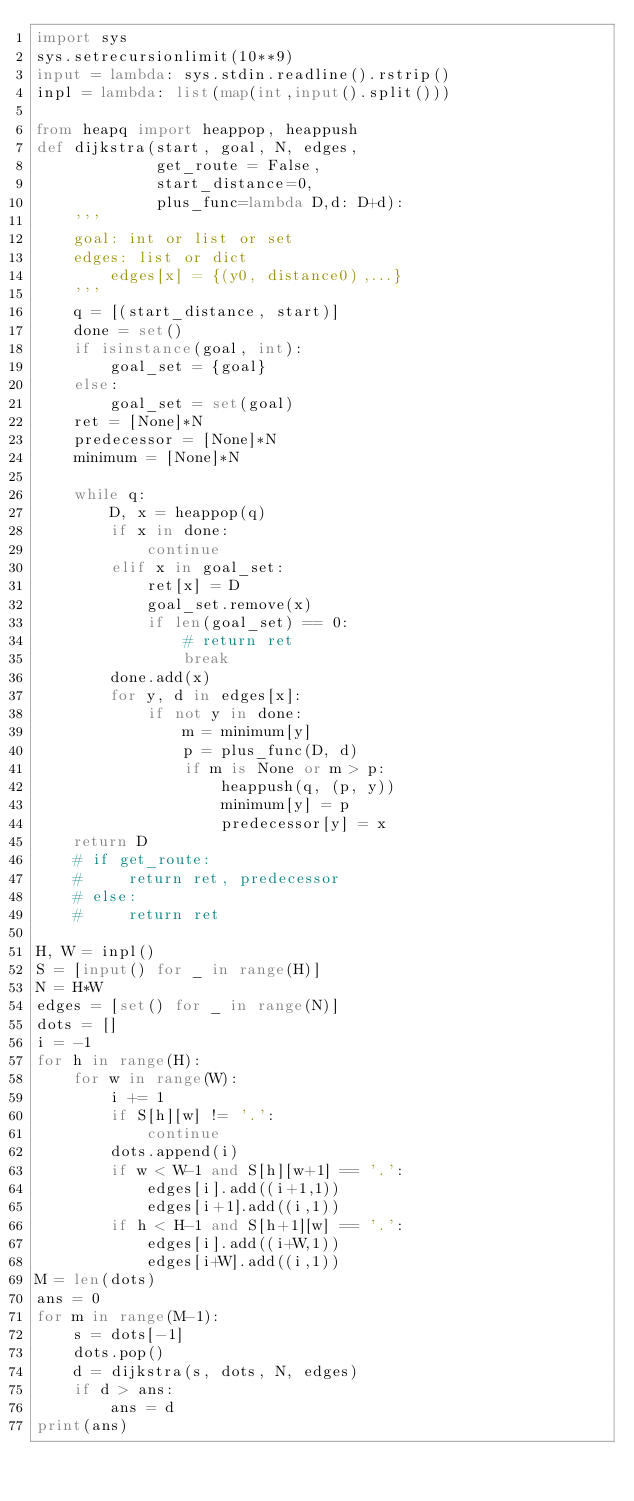<code> <loc_0><loc_0><loc_500><loc_500><_Python_>import sys
sys.setrecursionlimit(10**9)
input = lambda: sys.stdin.readline().rstrip()
inpl = lambda: list(map(int,input().split()))

from heapq import heappop, heappush
def dijkstra(start, goal, N, edges,
             get_route = False,
             start_distance=0,
             plus_func=lambda D,d: D+d):
    '''
    goal: int or list or set
    edges: list or dict
        edges[x] = {(y0, distance0),...}
    '''
    q = [(start_distance, start)]
    done = set()
    if isinstance(goal, int):
        goal_set = {goal}
    else:
        goal_set = set(goal)
    ret = [None]*N
    predecessor = [None]*N
    minimum = [None]*N

    while q:
        D, x = heappop(q)
        if x in done:
            continue
        elif x in goal_set:
            ret[x] = D
            goal_set.remove(x)
            if len(goal_set) == 0:
                # return ret
                break
        done.add(x)
        for y, d in edges[x]:
            if not y in done:
                m = minimum[y]
                p = plus_func(D, d)
                if m is None or m > p:
                    heappush(q, (p, y))
                    minimum[y] = p
                    predecessor[y] = x
    return D
    # if get_route:
    #     return ret, predecessor
    # else:
    #     return ret

H, W = inpl()
S = [input() for _ in range(H)]
N = H*W
edges = [set() for _ in range(N)]
dots = []
i = -1
for h in range(H):
    for w in range(W):
        i += 1
        if S[h][w] != '.':
            continue
        dots.append(i)
        if w < W-1 and S[h][w+1] == '.':
            edges[i].add((i+1,1))
            edges[i+1].add((i,1))
        if h < H-1 and S[h+1][w] == '.':
            edges[i].add((i+W,1))
            edges[i+W].add((i,1))
M = len(dots)
ans = 0
for m in range(M-1):
    s = dots[-1]
    dots.pop()
    d = dijkstra(s, dots, N, edges)
    if d > ans:
        ans = d
print(ans)</code> 